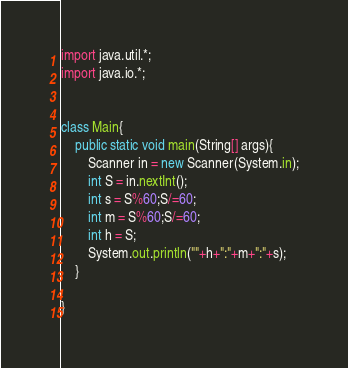Convert code to text. <code><loc_0><loc_0><loc_500><loc_500><_Java_>import java.util.*;
import java.io.*;


class Main{
    public static void main(String[] args){
        Scanner in = new Scanner(System.in);
        int S = in.nextInt();
        int s = S%60;S/=60;
        int m = S%60;S/=60;
        int h = S;
        System.out.println(""+h+":"+m+":"+s);
    }
    
}
</code> 